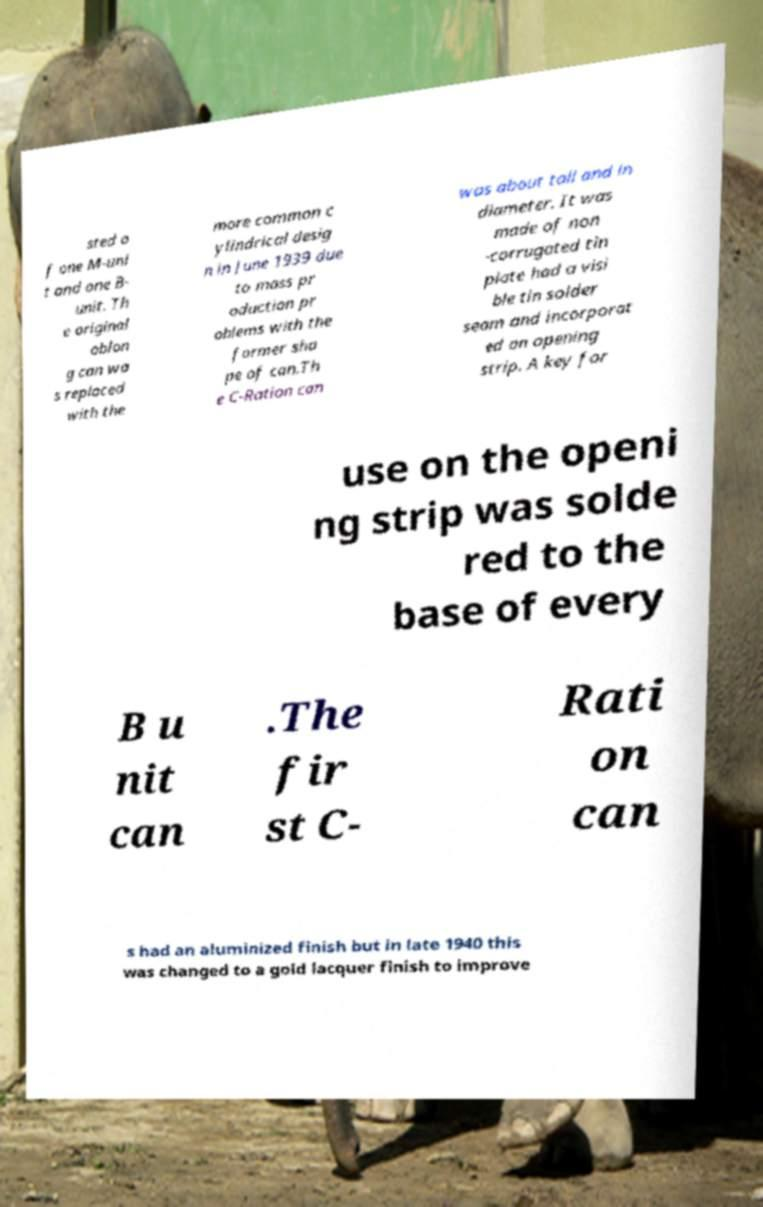Can you accurately transcribe the text from the provided image for me? sted o f one M-uni t and one B- unit. Th e original oblon g can wa s replaced with the more common c ylindrical desig n in June 1939 due to mass pr oduction pr oblems with the former sha pe of can.Th e C-Ration can was about tall and in diameter. It was made of non -corrugated tin plate had a visi ble tin solder seam and incorporat ed an opening strip. A key for use on the openi ng strip was solde red to the base of every B u nit can .The fir st C- Rati on can s had an aluminized finish but in late 1940 this was changed to a gold lacquer finish to improve 